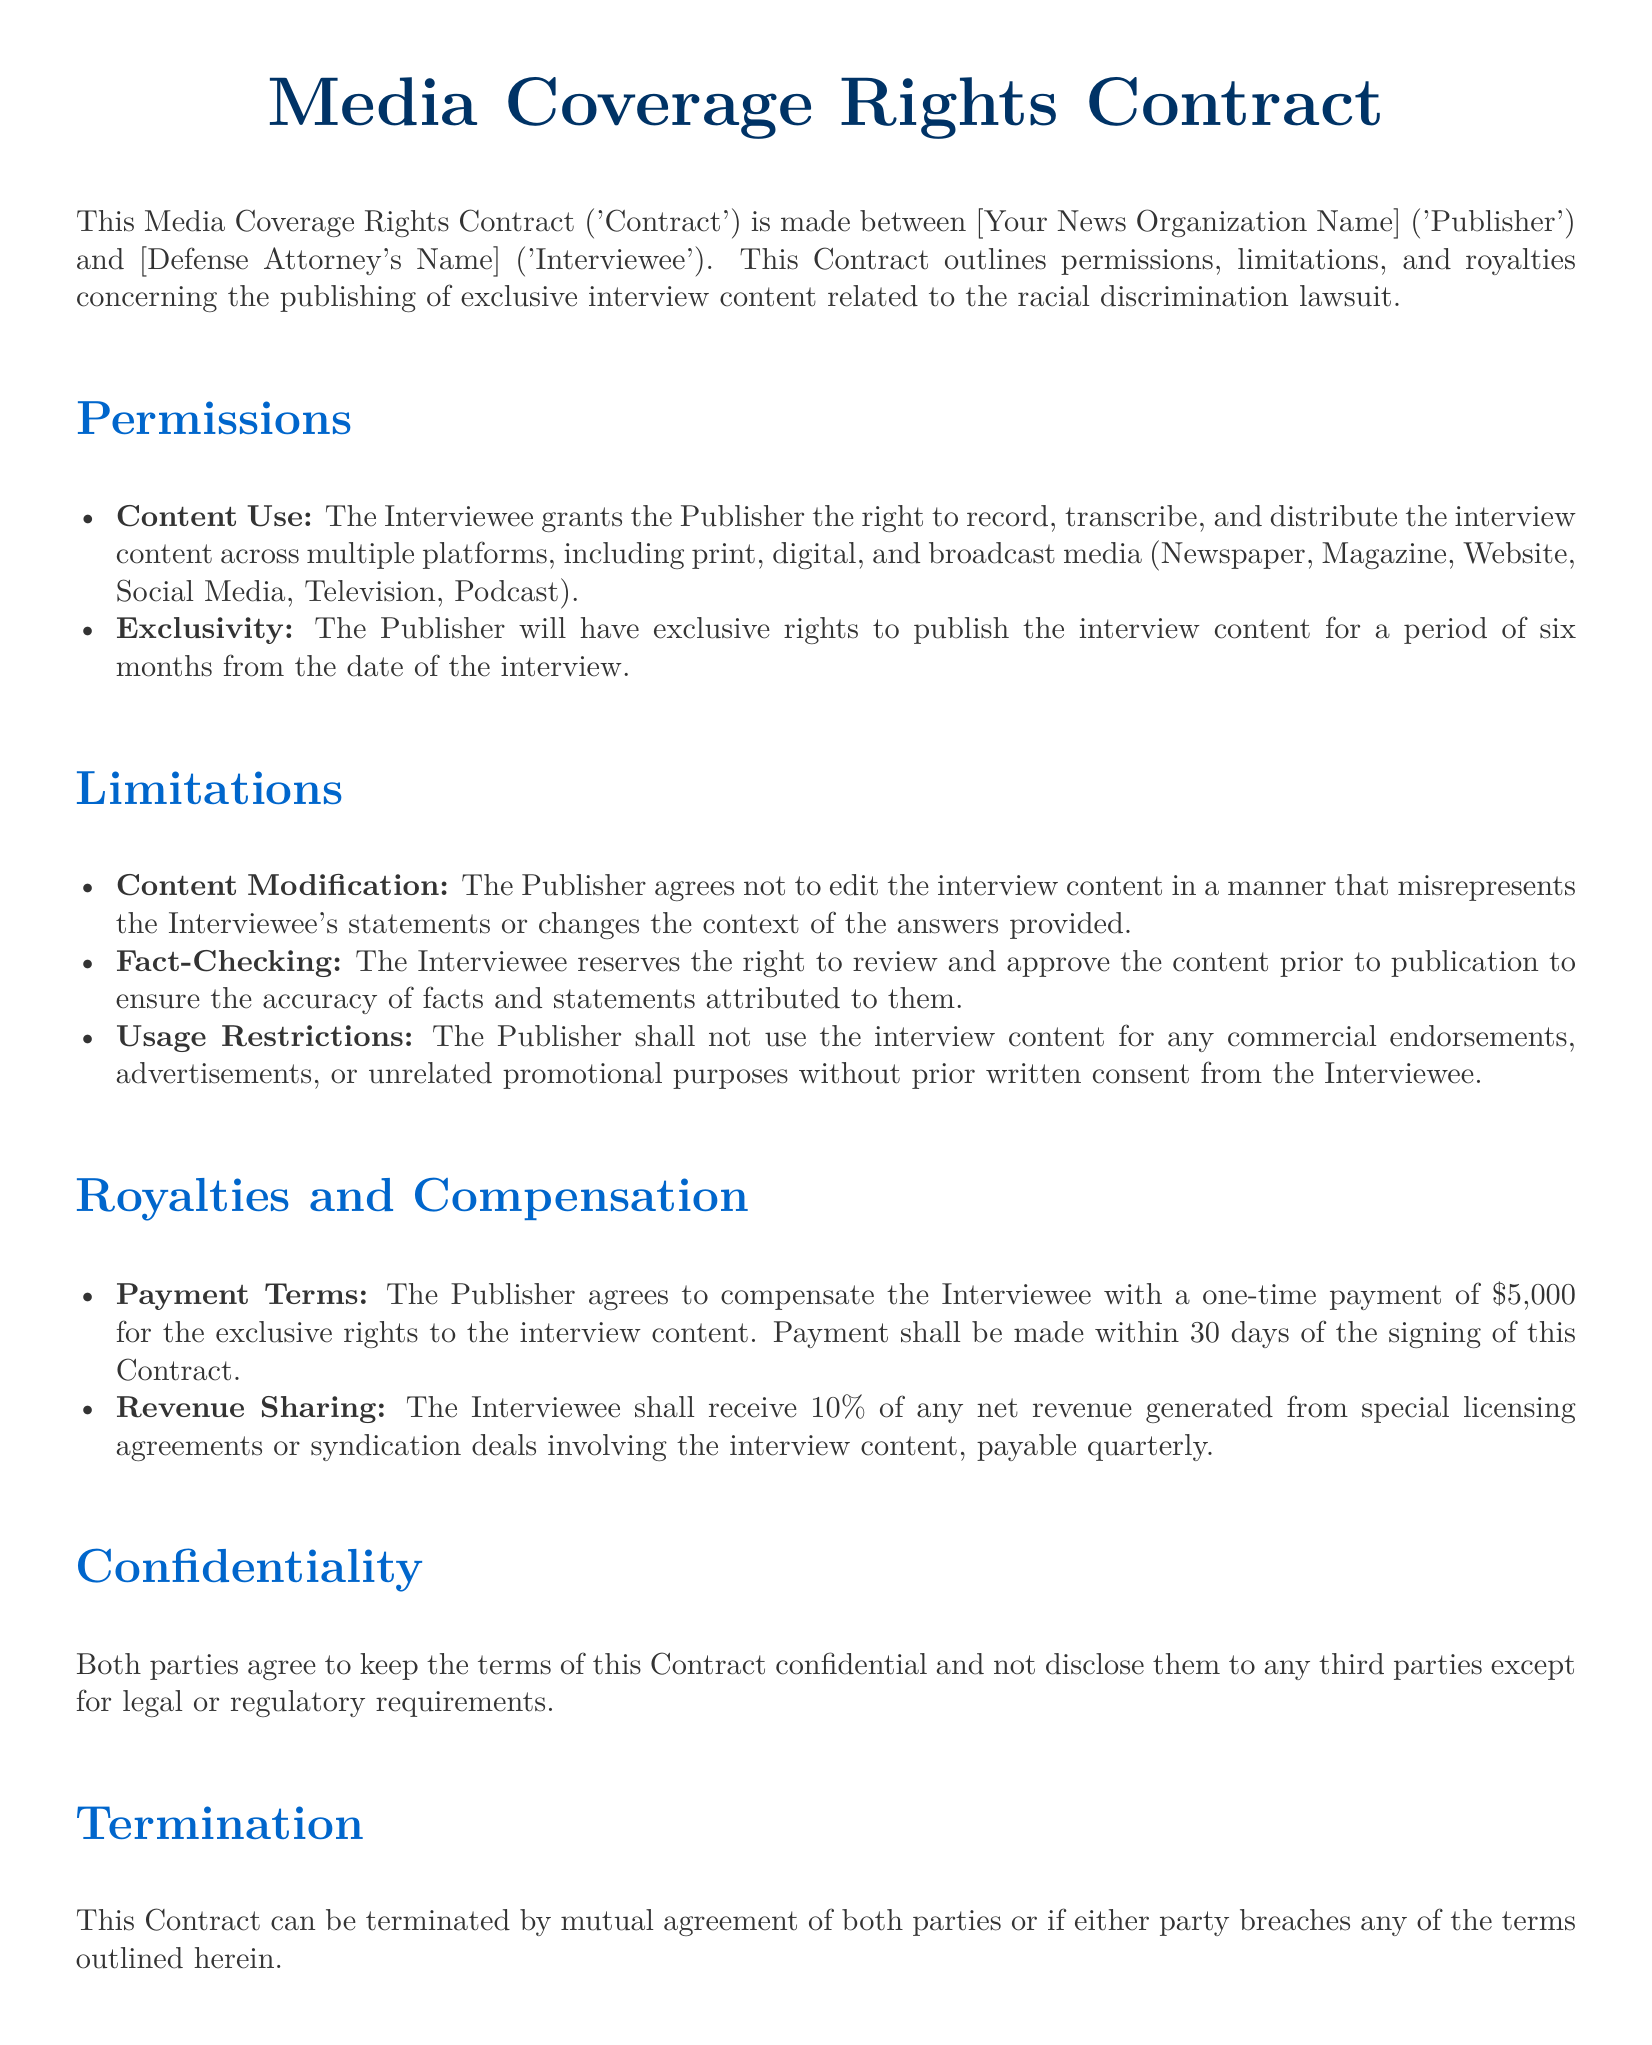what is the one-time payment amount for the exclusive rights? The document specifies a one-time payment of $5,000 for the exclusive rights to the interview content.
Answer: $5,000 how long is the exclusivity period for publishing the interview content? According to the document, the exclusivity period for publishing the interview content is six months from the date of the interview.
Answer: six months what percentage of revenue does the Interviewee receive from licensing agreements? The document states that the Interviewee shall receive 10% of any net revenue generated from special licensing agreements or syndication deals.
Answer: 10% what is the title of the document? The title of the document is prominently displayed at the top of the rendered document, stating "Media Coverage Rights Contract."
Answer: Media Coverage Rights Contract who must sign the contract for it to be valid? The document requires an authorized signature from both parties, the Publisher and the Interviewee, to make it valid.
Answer: both parties what right does the Interviewee reserve before publication? The Interviewee reserves the right to review and approve the content prior to publication to ensure accuracy.
Answer: review and approve what should the Publisher not use the interview content for? The Publisher shall not use the interview content for any commercial endorsements, advertisements, or unrelated promotional purposes without prior written consent.
Answer: commercial endorsements, advertisements how many days after signing must payment be made? The document specifies that payment shall be made within 30 days of the signing of the contract.
Answer: 30 days 